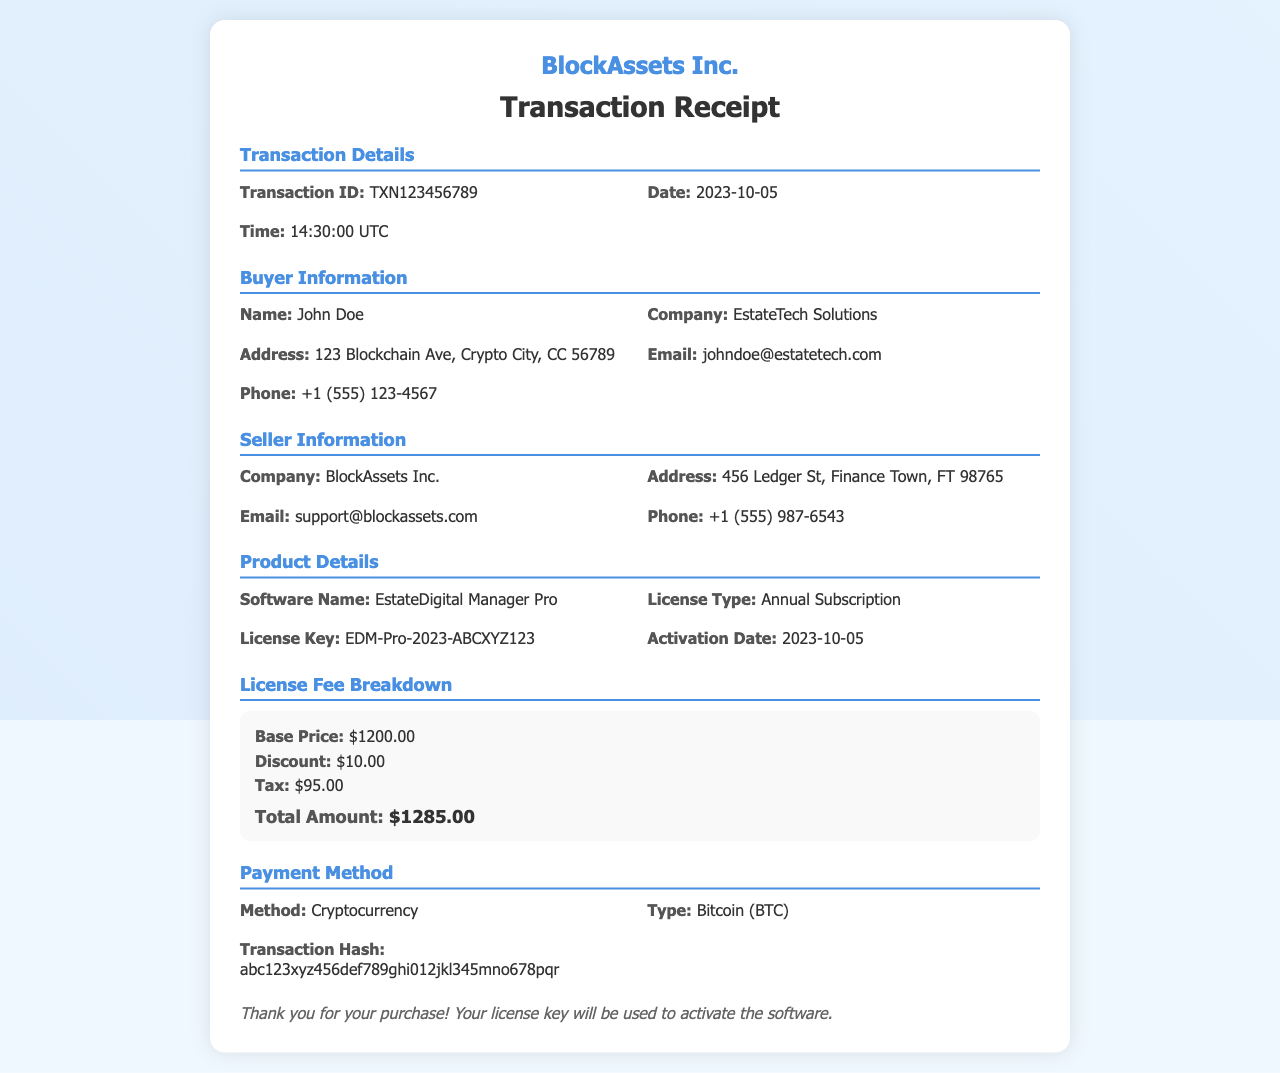What is the transaction ID? The transaction ID is a unique identifier for this particular transaction, which is listed in the document.
Answer: TXN123456789 Who is the buyer? The buyer information section lists the name of the person who made the purchase.
Answer: John Doe What date was the transaction completed? The date of the transaction is mentioned in the transaction details section.
Answer: 2023-10-05 What is the total amount of the license fee? The total amount is calculated from the fee breakdown provided in the document.
Answer: $1285.00 What kind of software was purchased? The product details section explicitly states the name of the software that was bought.
Answer: EstateDigital Manager Pro What is the license key? The license key is a unique identifier provided for the software, listed under product details.
Answer: EDM-Pro-2023-ABCXYZ123 What payment method was used? The payment method section outlines how the transaction was conducted, specifying the mode of payment.
Answer: Cryptocurrency What type of cryptocurrency was used for payment? The payment method details include the specific type of cryptocurrency involved in the transaction.
Answer: Bitcoin (BTC) What is the seller's company name? The seller information section identifies the company that sold the software.
Answer: BlockAssets Inc 